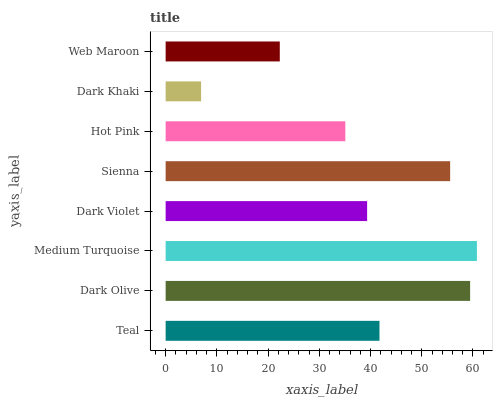Is Dark Khaki the minimum?
Answer yes or no. Yes. Is Medium Turquoise the maximum?
Answer yes or no. Yes. Is Dark Olive the minimum?
Answer yes or no. No. Is Dark Olive the maximum?
Answer yes or no. No. Is Dark Olive greater than Teal?
Answer yes or no. Yes. Is Teal less than Dark Olive?
Answer yes or no. Yes. Is Teal greater than Dark Olive?
Answer yes or no. No. Is Dark Olive less than Teal?
Answer yes or no. No. Is Teal the high median?
Answer yes or no. Yes. Is Dark Violet the low median?
Answer yes or no. Yes. Is Dark Olive the high median?
Answer yes or no. No. Is Teal the low median?
Answer yes or no. No. 